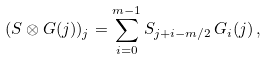Convert formula to latex. <formula><loc_0><loc_0><loc_500><loc_500>( S \otimes G ( j ) ) _ { j } = \sum _ { i = 0 } ^ { m - 1 } S _ { j + i - m / 2 } \, G _ { i } ( j ) \, ,</formula> 